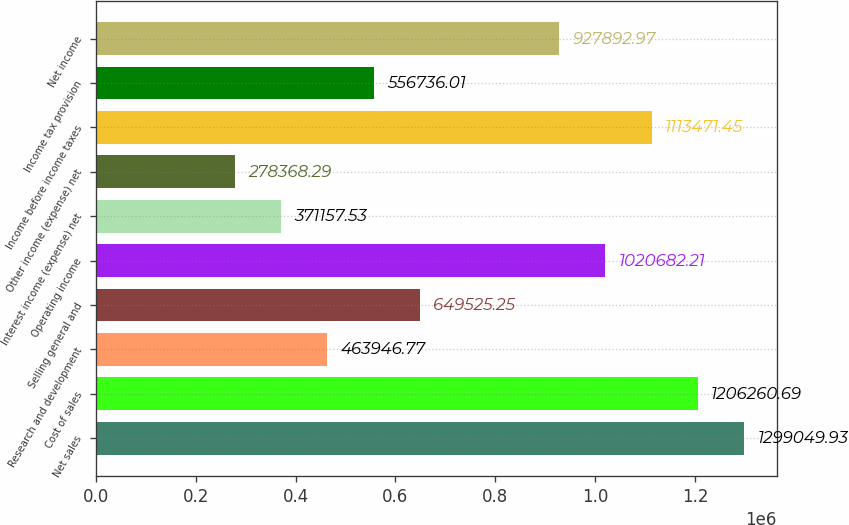Convert chart to OTSL. <chart><loc_0><loc_0><loc_500><loc_500><bar_chart><fcel>Net sales<fcel>Cost of sales<fcel>Research and development<fcel>Selling general and<fcel>Operating income<fcel>Interest income (expense) net<fcel>Other income (expense) net<fcel>Income before income taxes<fcel>Income tax provision<fcel>Net income<nl><fcel>1.29905e+06<fcel>1.20626e+06<fcel>463947<fcel>649525<fcel>1.02068e+06<fcel>371158<fcel>278368<fcel>1.11347e+06<fcel>556736<fcel>927893<nl></chart> 